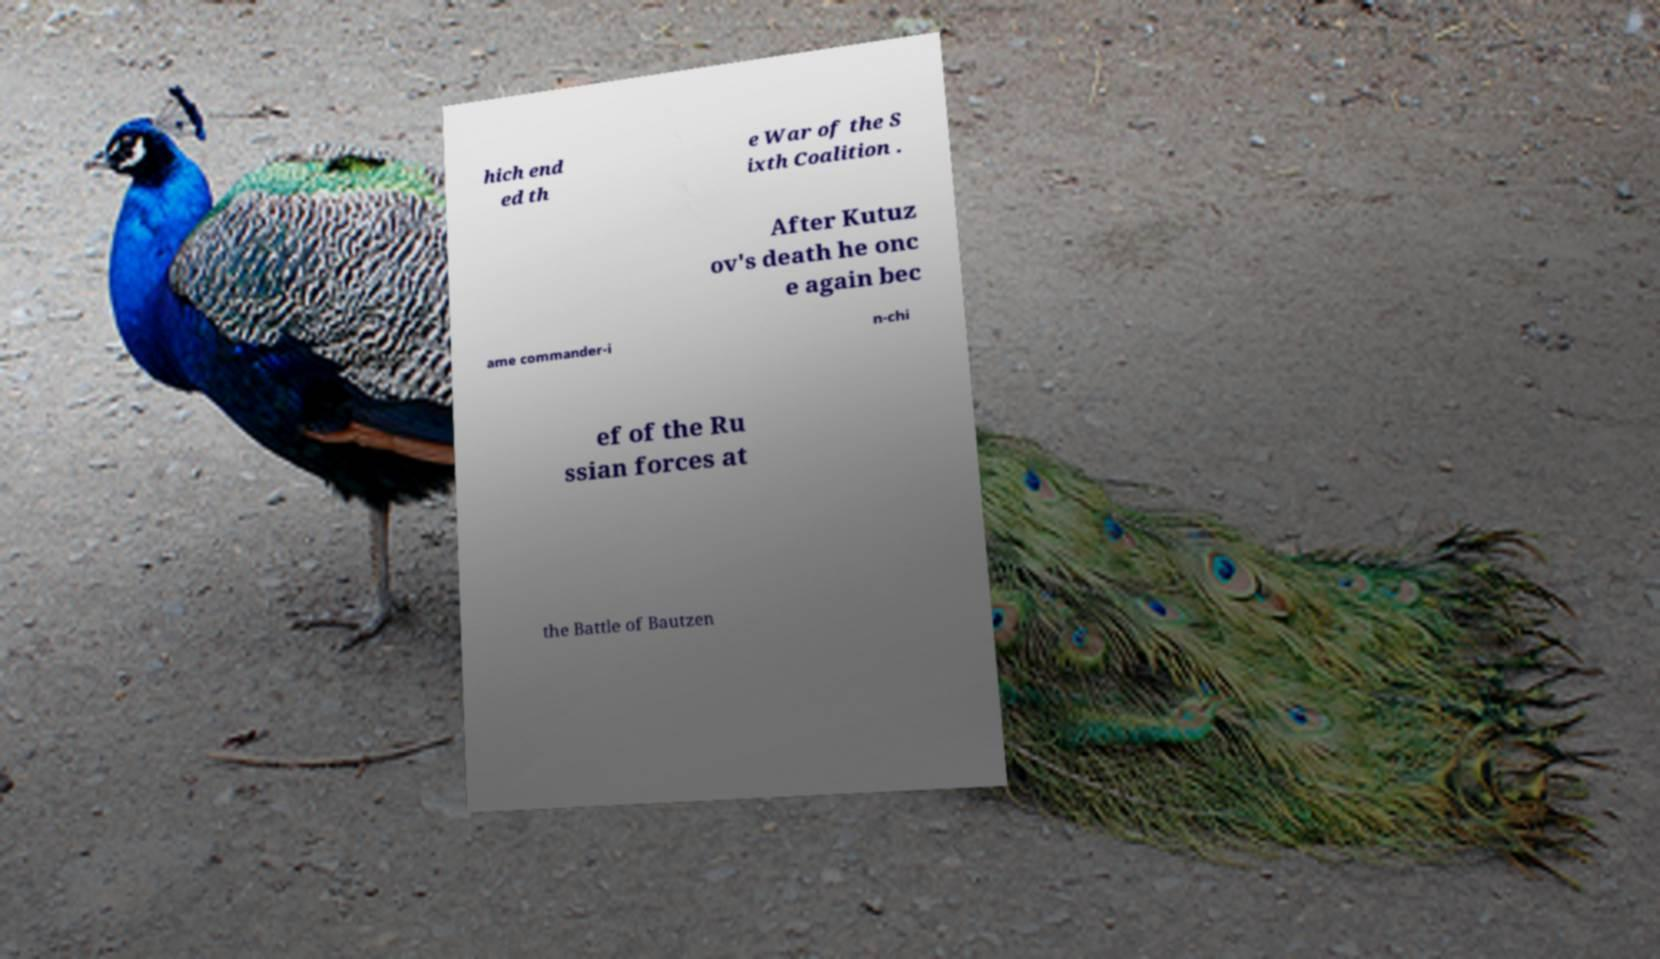Please identify and transcribe the text found in this image. hich end ed th e War of the S ixth Coalition . After Kutuz ov's death he onc e again bec ame commander-i n-chi ef of the Ru ssian forces at the Battle of Bautzen 